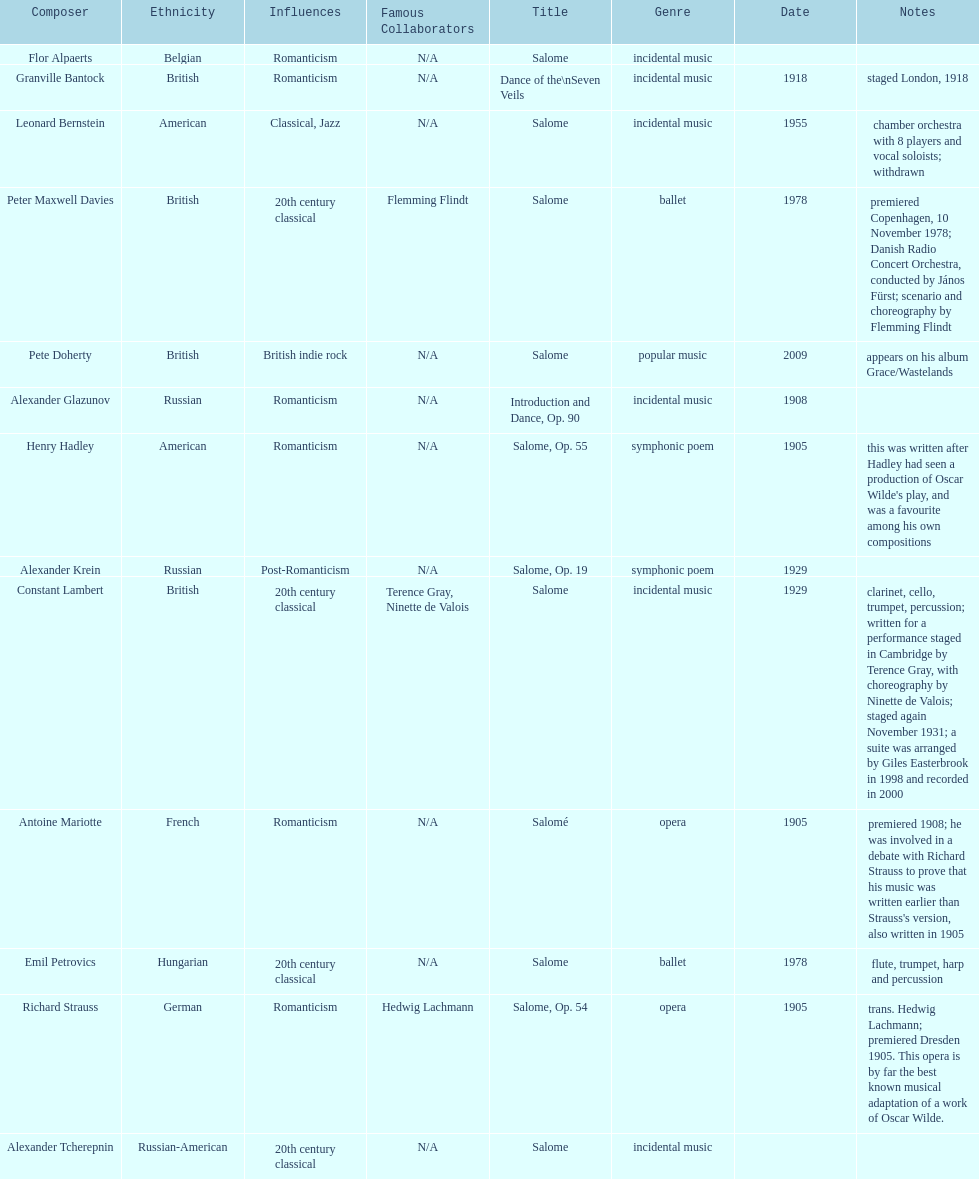What is the difference in years of granville bantock's work compared to pete dohert? 91. 